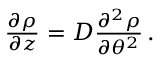<formula> <loc_0><loc_0><loc_500><loc_500>\begin{array} { r } { { \frac { \partial \rho } { \partial z } } = D { \frac { \partial ^ { 2 } \rho } { \partial \theta ^ { 2 } } } \, . } \end{array}</formula> 